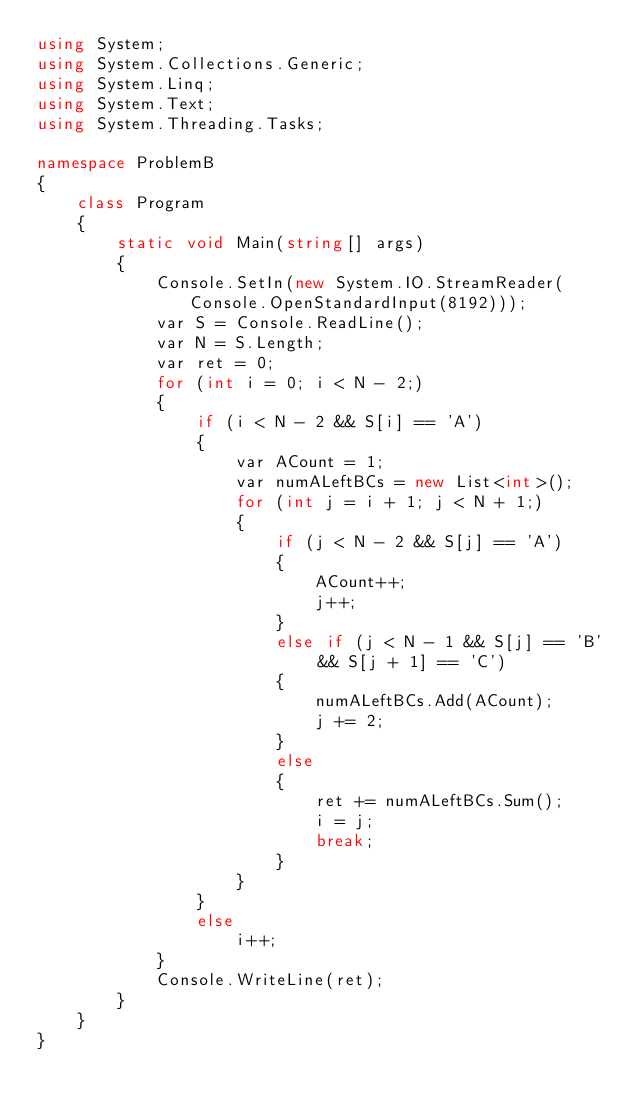Convert code to text. <code><loc_0><loc_0><loc_500><loc_500><_C#_>using System;
using System.Collections.Generic;
using System.Linq;
using System.Text;
using System.Threading.Tasks;

namespace ProblemB
{
    class Program
    {
        static void Main(string[] args)
        {
            Console.SetIn(new System.IO.StreamReader(Console.OpenStandardInput(8192)));
            var S = Console.ReadLine();
            var N = S.Length;
            var ret = 0;
            for (int i = 0; i < N - 2;)
            {
                if (i < N - 2 && S[i] == 'A')
                {
                    var ACount = 1;
                    var numALeftBCs = new List<int>();
                    for (int j = i + 1; j < N + 1;)
                    {
                        if (j < N - 2 && S[j] == 'A')
                        {
                            ACount++;
                            j++;
                        }
                        else if (j < N - 1 && S[j] == 'B' && S[j + 1] == 'C')
                        {
                            numALeftBCs.Add(ACount);
                            j += 2;
                        }
                        else
                        {
                            ret += numALeftBCs.Sum();
                            i = j;
                            break;
                        }
                    }
                }
                else
                    i++;
            }
            Console.WriteLine(ret);
        }
    }
}
</code> 